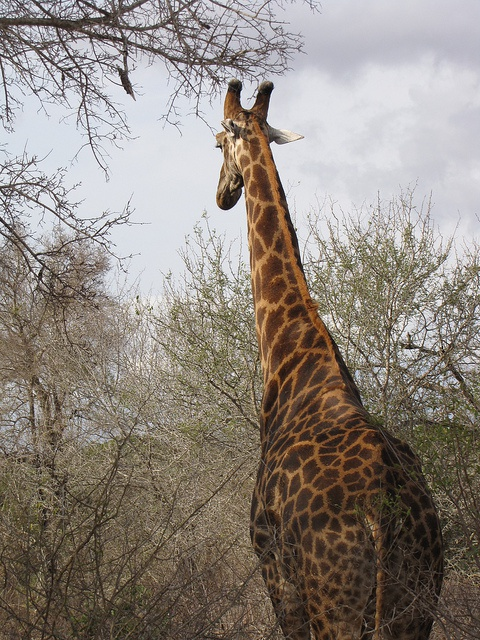Describe the objects in this image and their specific colors. I can see a giraffe in gray, black, maroon, and brown tones in this image. 